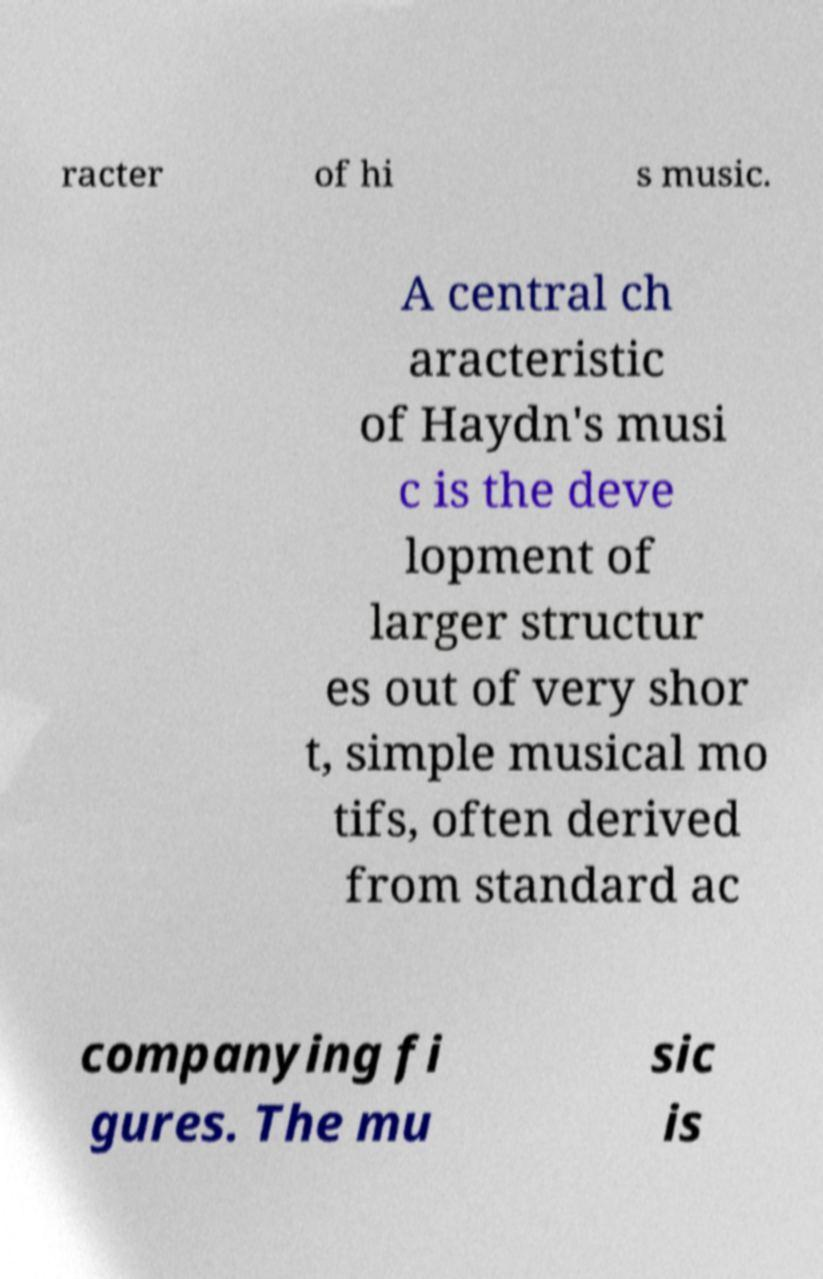Could you assist in decoding the text presented in this image and type it out clearly? racter of hi s music. A central ch aracteristic of Haydn's musi c is the deve lopment of larger structur es out of very shor t, simple musical mo tifs, often derived from standard ac companying fi gures. The mu sic is 